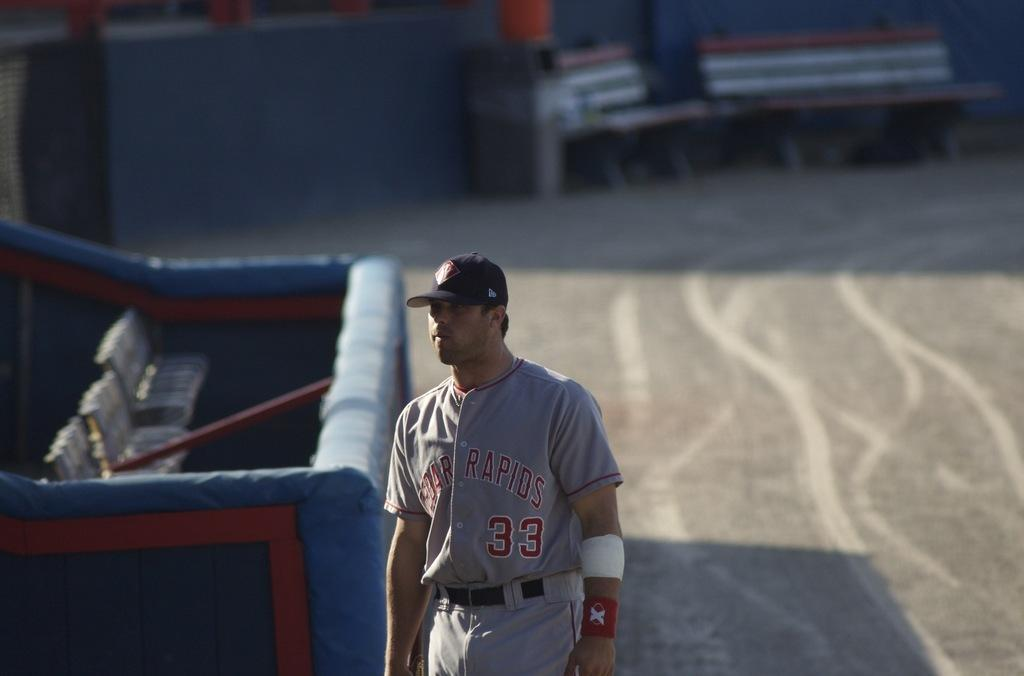<image>
Offer a succinct explanation of the picture presented. A player for the Cedar Rapids baseball team walks near the dugout. 